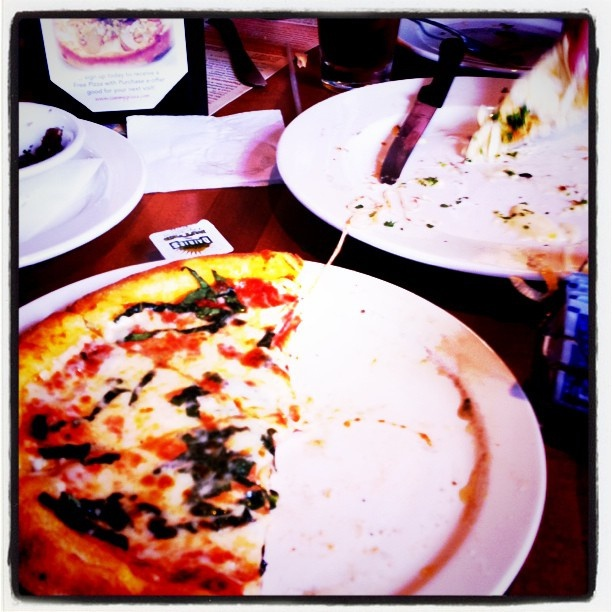Describe the objects in this image and their specific colors. I can see pizza in white, black, brown, and red tones, dining table in white, black, maroon, lavender, and brown tones, pizza in white, lightgray, black, tan, and maroon tones, bowl in white, lavender, black, and purple tones, and pizza in white, pink, lightgray, violet, and darkgray tones in this image. 